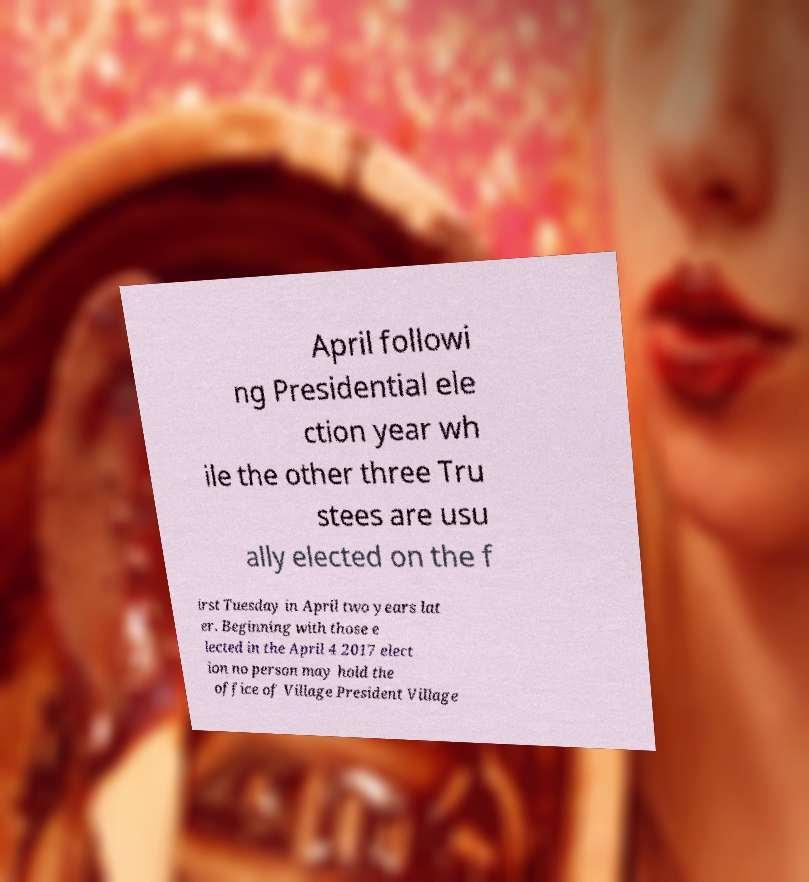Can you read and provide the text displayed in the image?This photo seems to have some interesting text. Can you extract and type it out for me? April followi ng Presidential ele ction year wh ile the other three Tru stees are usu ally elected on the f irst Tuesday in April two years lat er. Beginning with those e lected in the April 4 2017 elect ion no person may hold the office of Village President Village 